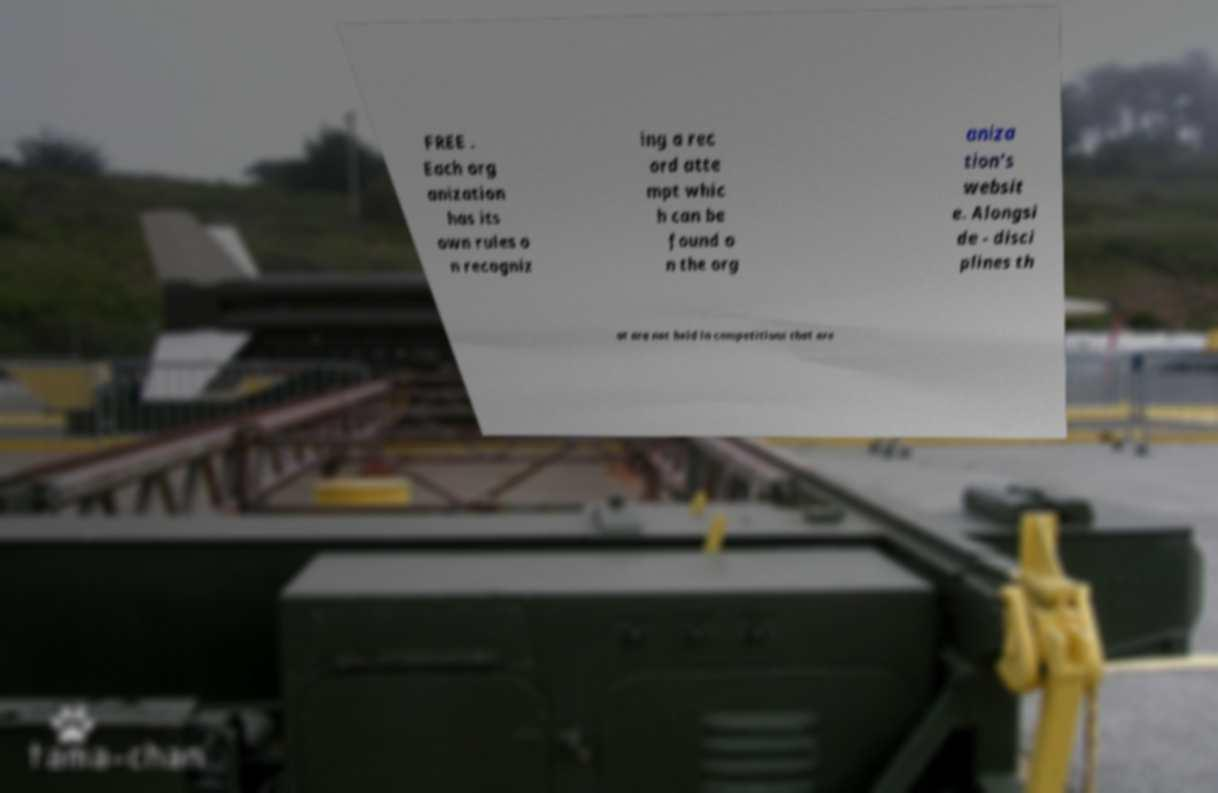Can you accurately transcribe the text from the provided image for me? FREE . Each org anization has its own rules o n recogniz ing a rec ord atte mpt whic h can be found o n the org aniza tion's websit e. Alongsi de - disci plines th at are not held in competitions that are 